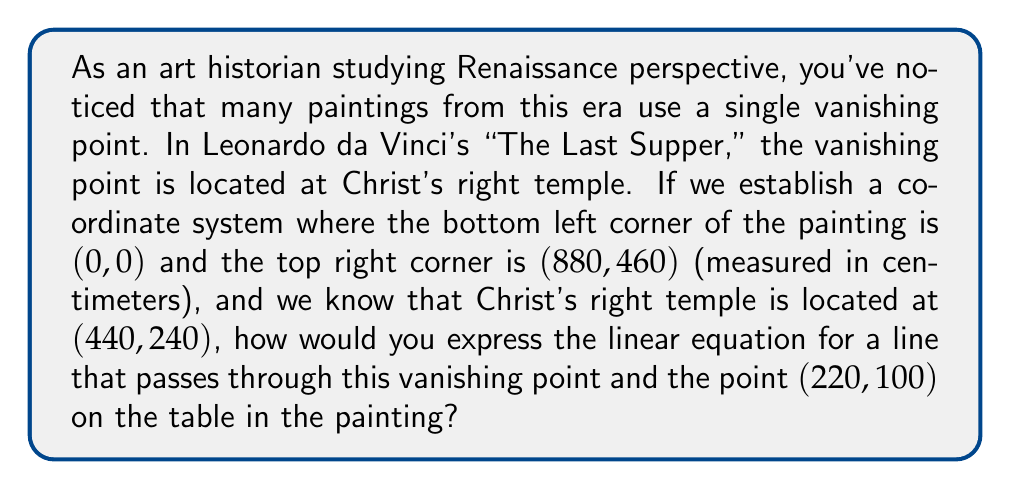Can you solve this math problem? To solve this problem, we'll use the point-slope form of a linear equation. The steps are as follows:

1) We have two points:
   - The vanishing point (Christ's right temple): $(x_1, y_1) = (440, 240)$
   - A point on the table: $(x_2, y_2) = (220, 100)$

2) The slope of the line can be calculated using the formula:
   
   $m = \frac{y_2 - y_1}{x_2 - x_1} = \frac{100 - 240}{220 - 440} = \frac{-140}{-220} = \frac{7}{11}$

3) Now that we have the slope and a point (let's use the vanishing point), we can use the point-slope form of a line:

   $y - y_1 = m(x - x_1)$

4) Substituting our values:

   $y - 240 = \frac{7}{11}(x - 440)$

5) This is the linear equation in point-slope form. We can convert it to slope-intercept form $(y = mx + b)$ if desired:

   $y - 240 = \frac{7}{11}x - \frac{7}{11}(440)$
   $y = \frac{7}{11}x - \frac{3080}{11} + 240$
   $y = \frac{7}{11}x + \frac{-3080 + 2640}{11}$
   $y = \frac{7}{11}x - 40$

This equation represents one of the many lines in the painting that would converge at the vanishing point, helping to create the illusion of depth and perspective characteristic of Renaissance art.
Answer: The linear equation for the line passing through the vanishing point (440, 240) and the point (220, 100) on the table is:

$y = \frac{7}{11}x - 40$

or in point-slope form:

$y - 240 = \frac{7}{11}(x - 440)$ 